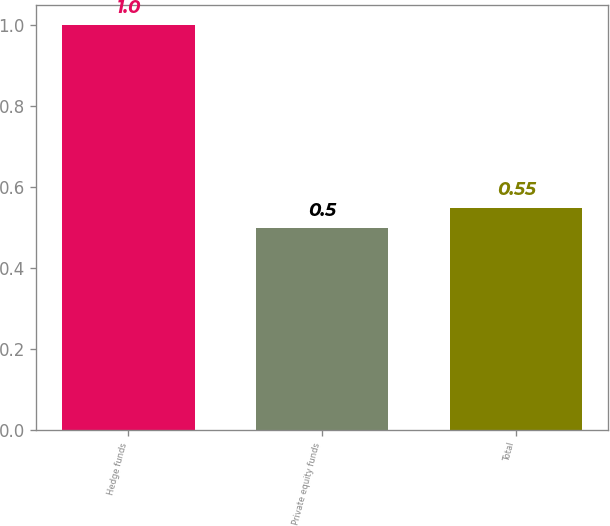<chart> <loc_0><loc_0><loc_500><loc_500><bar_chart><fcel>Hedge funds<fcel>Private equity funds<fcel>Total<nl><fcel>1<fcel>0.5<fcel>0.55<nl></chart> 